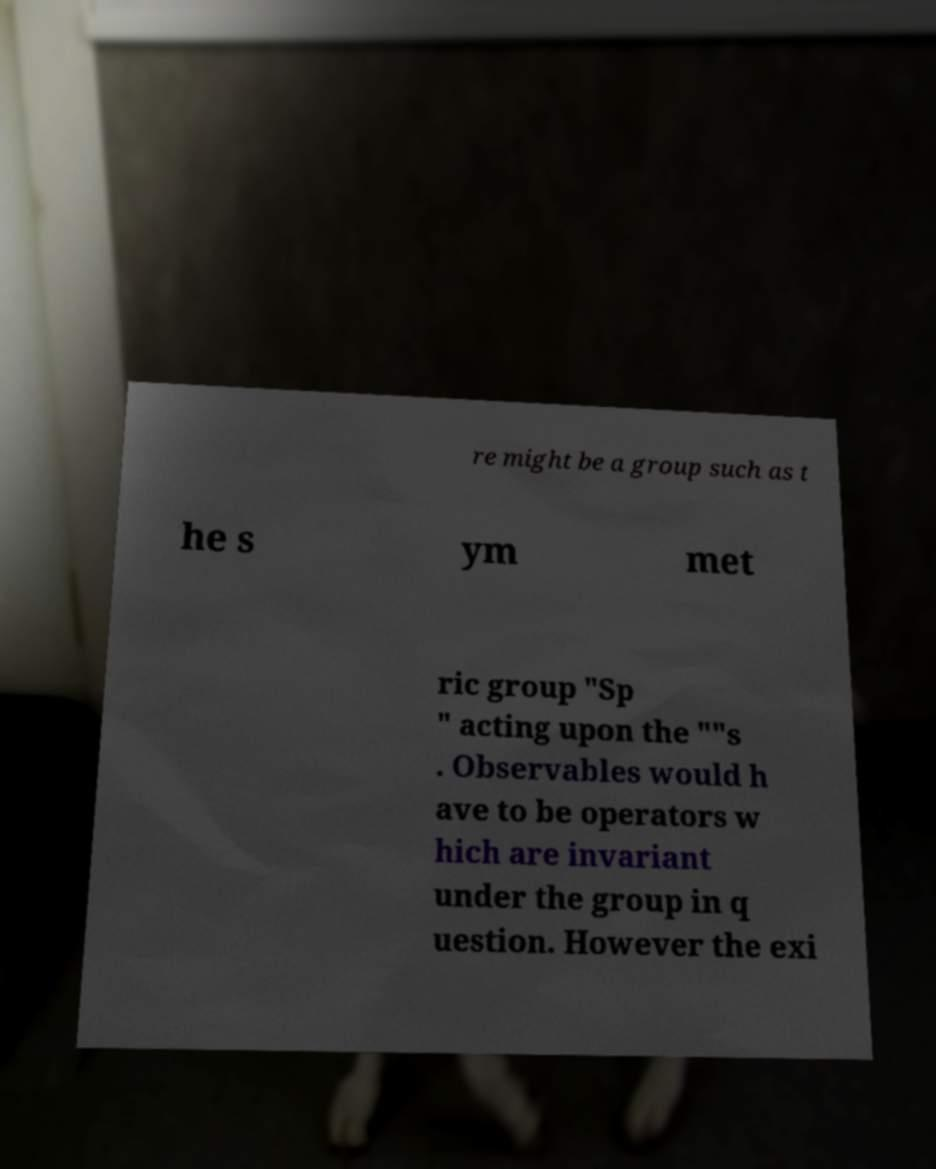Could you assist in decoding the text presented in this image and type it out clearly? re might be a group such as t he s ym met ric group "Sp " acting upon the ""s . Observables would h ave to be operators w hich are invariant under the group in q uestion. However the exi 